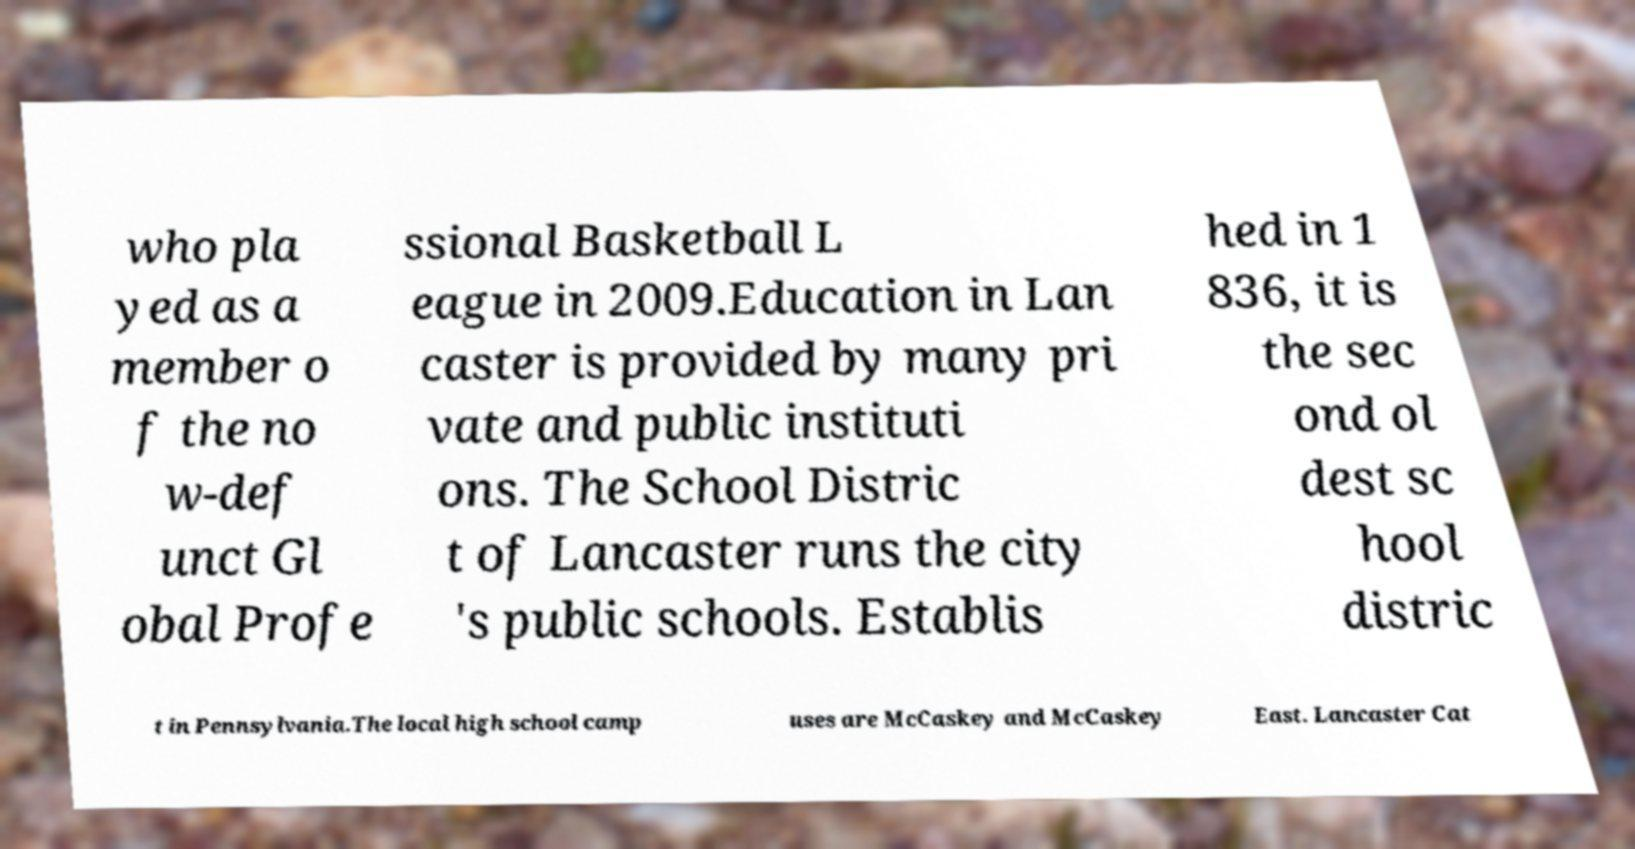Please read and relay the text visible in this image. What does it say? who pla yed as a member o f the no w-def unct Gl obal Profe ssional Basketball L eague in 2009.Education in Lan caster is provided by many pri vate and public instituti ons. The School Distric t of Lancaster runs the city 's public schools. Establis hed in 1 836, it is the sec ond ol dest sc hool distric t in Pennsylvania.The local high school camp uses are McCaskey and McCaskey East. Lancaster Cat 